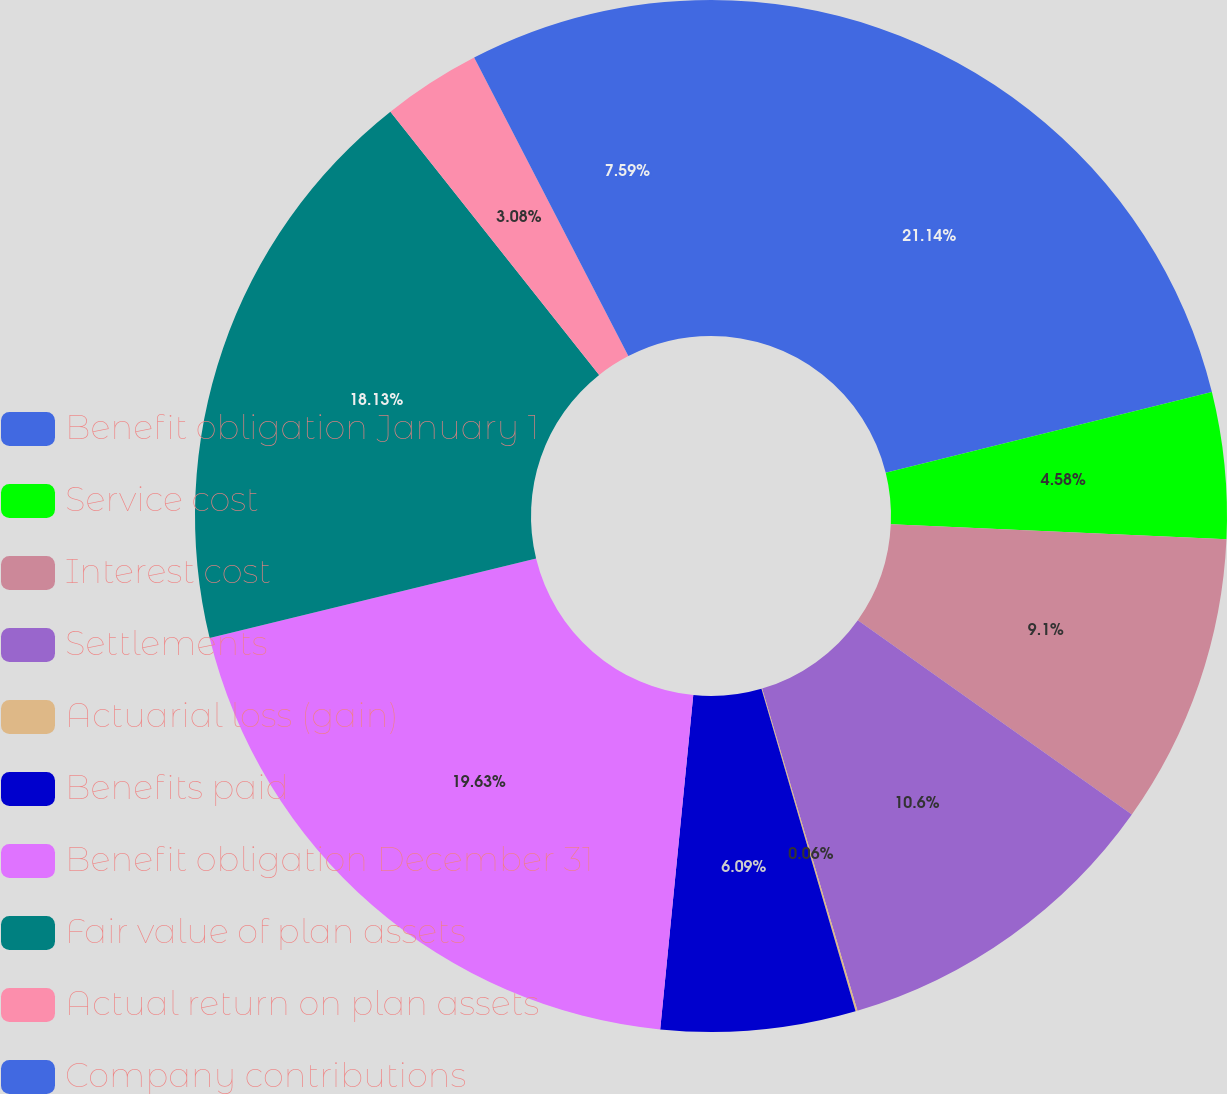<chart> <loc_0><loc_0><loc_500><loc_500><pie_chart><fcel>Benefit obligation January 1<fcel>Service cost<fcel>Interest cost<fcel>Settlements<fcel>Actuarial loss (gain)<fcel>Benefits paid<fcel>Benefit obligation December 31<fcel>Fair value of plan assets<fcel>Actual return on plan assets<fcel>Company contributions<nl><fcel>21.14%<fcel>4.58%<fcel>9.1%<fcel>10.6%<fcel>0.06%<fcel>6.09%<fcel>19.63%<fcel>18.13%<fcel>3.08%<fcel>7.59%<nl></chart> 